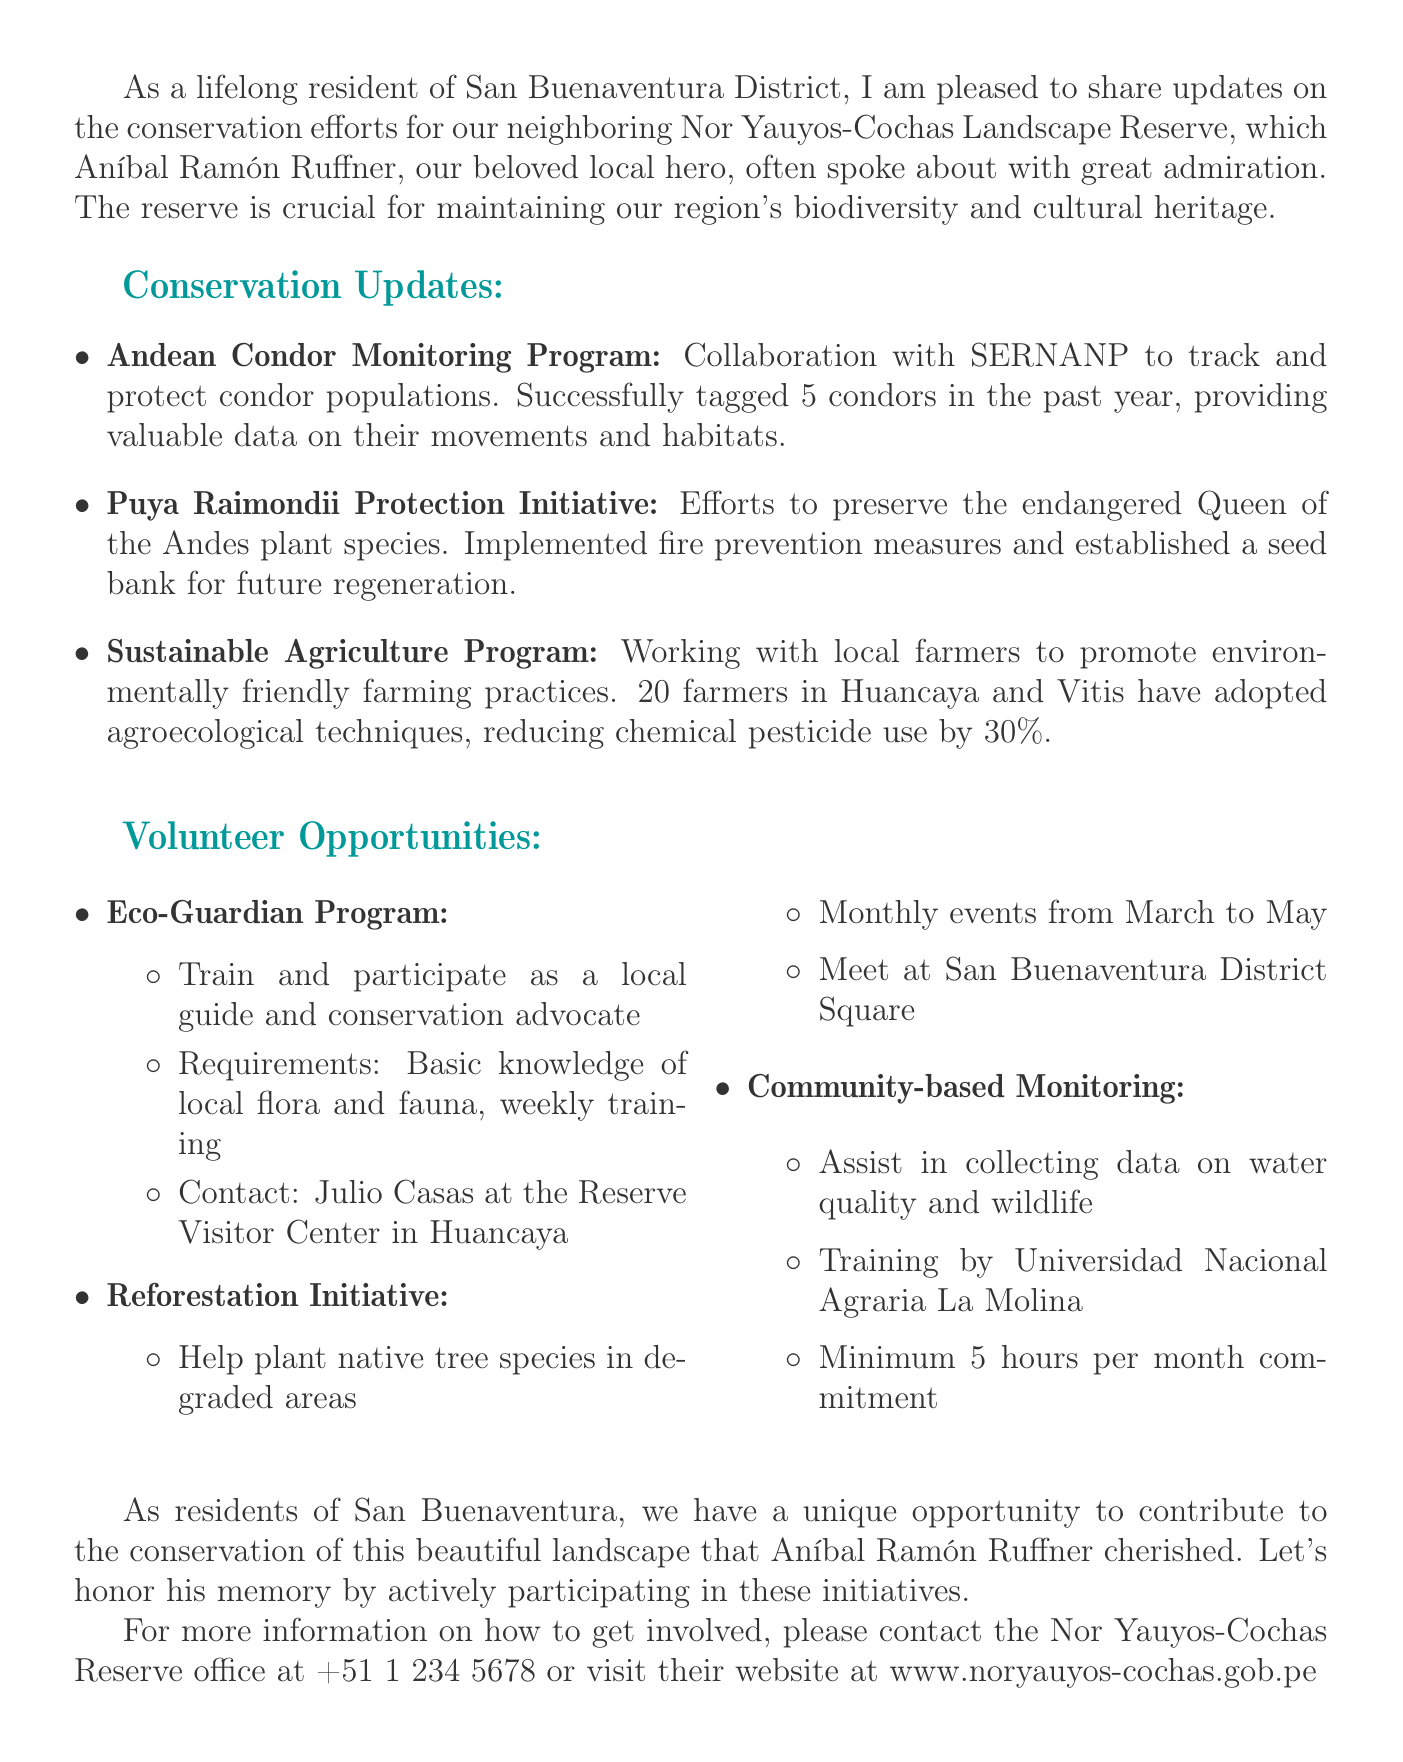what is the title of the memo? The title of the memo is explicitly stated at the beginning, as "Update on Conservation Efforts for Nor Yauyos-Cochas Landscape Reserve."
Answer: Update on Conservation Efforts for Nor Yauyos-Cochas Landscape Reserve who collaborated on the Andean Condor Monitoring Program? The document specifies that the program is in collaboration with SERNANP, which stands for National Service of Natural Protected Areas.
Answer: SERNANP how many condors were tagged in the past year? The memo reports that 5 condors have been tagged in the previous year as part of the monitoring effort.
Answer: 5 what percentage of chemical pesticide use was reduced in the Sustainable Agriculture Program? The document notes that the reduction in chemical pesticide use achieved by local farmers is 30 percent due to the adoption of agroecological techniques.
Answer: 30% what is required to join the Eco-Guardian Program? The document mentions that joining the Eco-Guardian Program requires basic knowledge of local flora and fauna and a willingness to attend weekly training sessions.
Answer: Basic knowledge of local flora and fauna how often will planting events take place in the Reforestation Initiative? The memo indicates that the reforestation planting events are scheduled to occur monthly from March to May.
Answer: Monthly which university provides training for the Community-based Monitoring program? The document specifies that the training for the Community-based Monitoring program is provided by Universidad Nacional Agraria La Molina.
Answer: Universidad Nacional Agraria La Molina what is the minimum time commitment for the Community-based Monitoring program? According to the memo, the minimum time commitment required for participants in the Community-based Monitoring program is 5 hours per month.
Answer: 5 hours per month who should be contacted for more information about getting involved? The document provides contact information for the Nor Yauyos-Cochas Reserve office, which is the appropriate contact for more information.
Answer: Nor Yauyos-Cochas Reserve office 